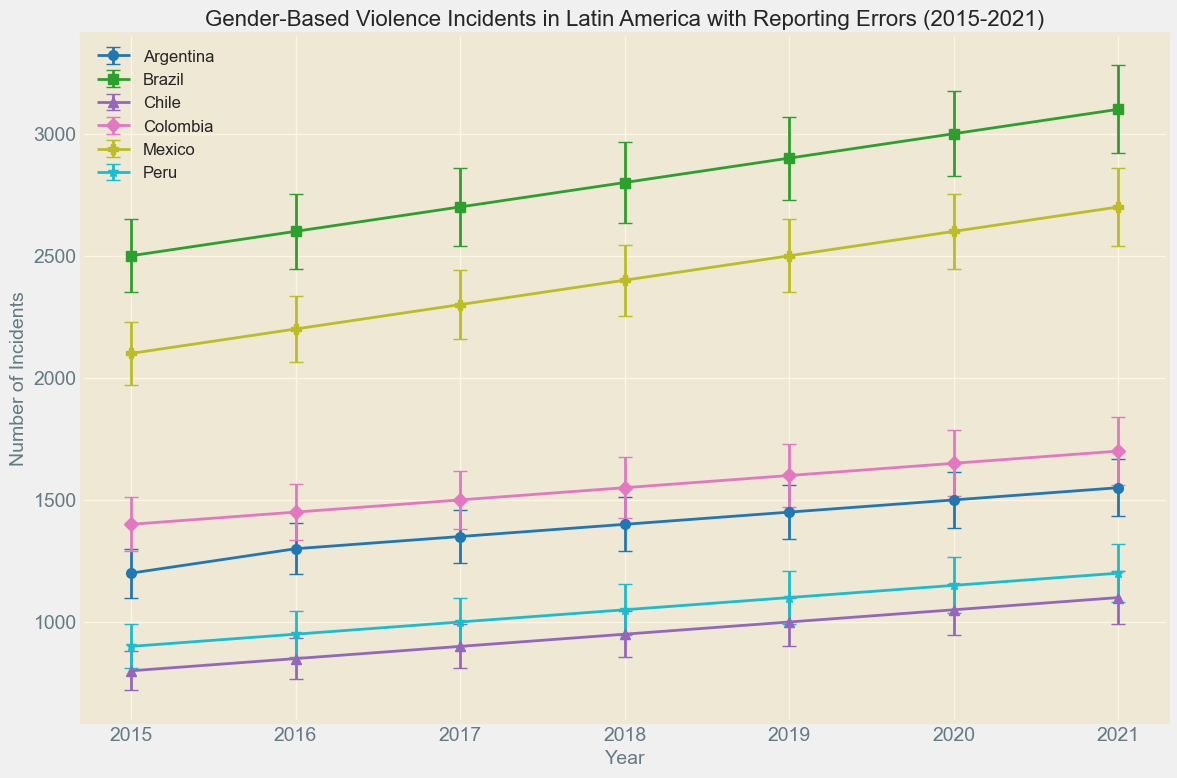Which country had the highest number of gender-based violence incidents in 2019? In the 2019 data, Brazil had the highest number of incidents with 2900 cases compared to the other countries.
Answer: Brazil What is the average number of incidents in Argentina from 2015 to 2021? Adding the incidents for each year in Argentina from 2015 to 2021 (1200 + 1300 + 1350 + 1400 + 1450 + 1500 + 1550) gives a total of 9750, and dividing by 7 years gives an average of approximately 1393 incidents per year.
Answer: 1393 Which country had the largest increase in incidents between 2015 and 2021? Comparing the difference in incidents between 2015 and 2021 across all countries (i.e., Brazil: 2500 to 3100, Argentina: 1200 to 1550, etc.), Brazil had the largest increase with a difference of 600 incidents.
Answer: Brazil In which year did Mexico have the highest number of incidents? Reviewing Mexico's incidents data from 2015 to 2021, the highest number occurred in 2021 with 2700 incidents.
Answer: 2021 Comparing Chile and Peru, which country reported more average incidents per year from 2015 to 2021? The average for Chile is (800 + 850 + 900 + 950 + 1000 + 1050 + 1100) / 7 = 950, and for Peru (900 + 950 + 1000 + 1050 + 1100 + 1150 + 1200) / 7 = 1064.3, so Peru had more average incidents.
Answer: Peru What is the trend in the number of incidents in Colombia from 2015 to 2021, and what could this indicate? Observing Colombia's data, the incidents increased steadily from 1400 in 2015 to 1700 in 2021, indicating a rising trend in reported gender-based violence incidents over this period.
Answer: Increasing trend Which country had the smallest standard error in reporting in 2016? Among the standard errors for 2016, Chile reported the smallest standard error of 85.
Answer: Chile How much did the number of incidents in Brazil change from 2017 to 2020? The number of incidents in Brazil increased from 2700 in 2017 to 3000 in 2020, resulting in a change of 300 incidents.
Answer: 300 What visual pattern can you observe in the error margins for Mexico across the years 2015 to 2021? The error margins for Mexico appear to increase slightly each year from 130 in 2015 to 160 in 2021, suggesting increasing variability or uncertainty in reporting over these years.
Answer: Increasing error margins Which two countries had the closest number of reported incidents in 2021 and what were their incident counts? In 2021, Chile and Peru had similar incident counts of 1100 and 1200 respectively, making them the closest in reported incidents that year.
Answer: Chile: 1100, Peru: 1200 